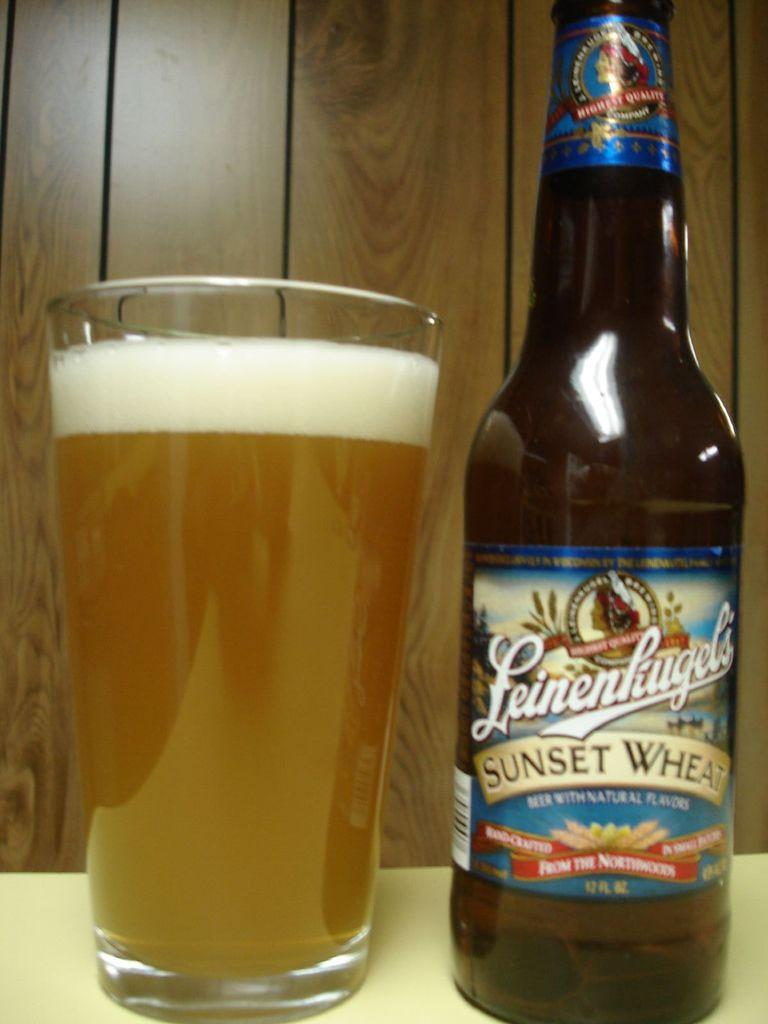<image>
Offer a succinct explanation of the picture presented. Glass and bottle of Leinenhugel's Sunset Wheat beer 